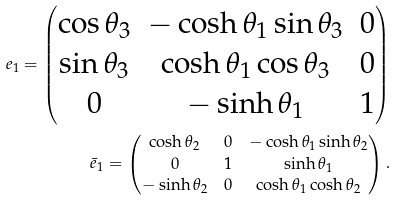Convert formula to latex. <formula><loc_0><loc_0><loc_500><loc_500>e _ { 1 } = \begin{pmatrix} \cos \theta _ { 3 } & - \cosh \theta _ { 1 } \sin \theta _ { 3 } & 0 \\ \sin \theta _ { 3 } & \cosh \theta _ { 1 } \cos \theta _ { 3 } & 0 \\ 0 & - \sinh \theta _ { 1 } & 1 \end{pmatrix} \\ \bar { e } _ { 1 } = \begin{pmatrix} \cosh \theta _ { 2 } & 0 & - \cosh \theta _ { 1 } \sinh \theta _ { 2 } \\ 0 & 1 & \sinh \theta _ { 1 } \\ - \sinh \theta _ { 2 } & 0 & \cosh \theta _ { 1 } \cosh \theta _ { 2 } \end{pmatrix} .</formula> 